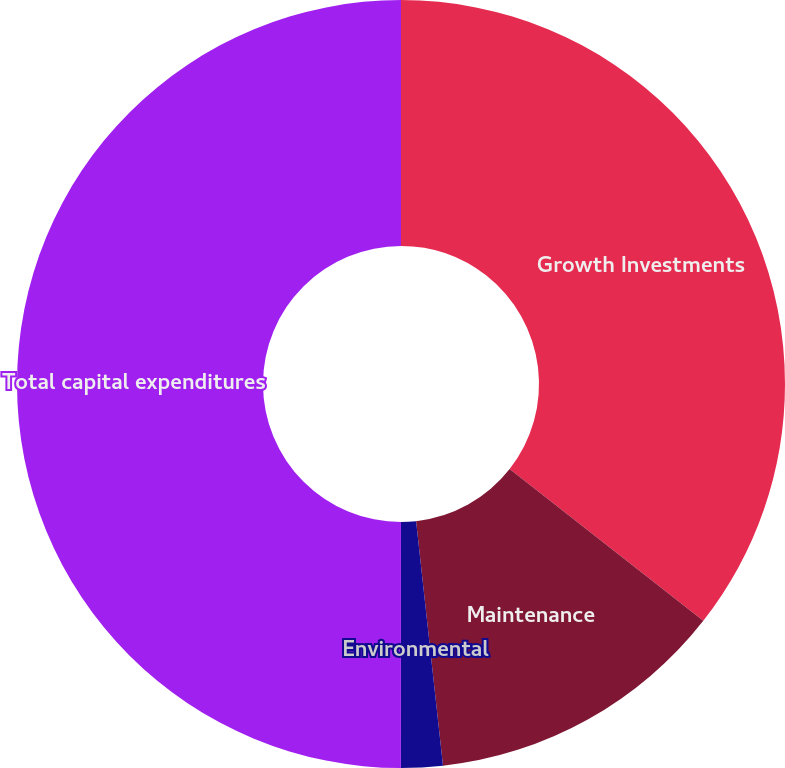Convert chart. <chart><loc_0><loc_0><loc_500><loc_500><pie_chart><fcel>Growth Investments<fcel>Maintenance<fcel>Environmental<fcel>Total capital expenditures<nl><fcel>35.58%<fcel>12.68%<fcel>1.75%<fcel>50.0%<nl></chart> 